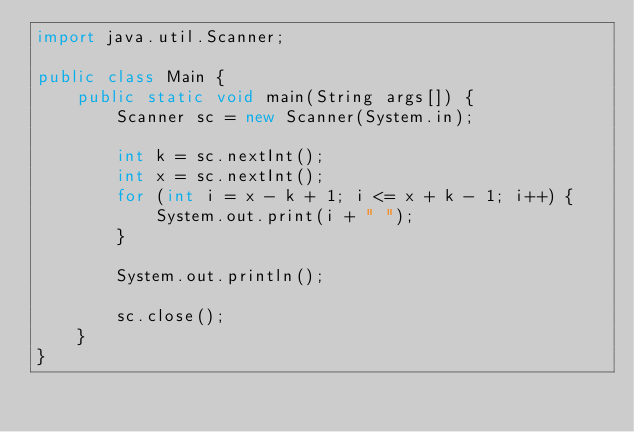<code> <loc_0><loc_0><loc_500><loc_500><_Java_>import java.util.Scanner;

public class Main {
	public static void main(String args[]) {
		Scanner sc = new Scanner(System.in);

		int k = sc.nextInt();
		int x = sc.nextInt();
		for (int i = x - k + 1; i <= x + k - 1; i++) {
			System.out.print(i + " ");
		}

		System.out.println();

		sc.close();
	}
}
</code> 